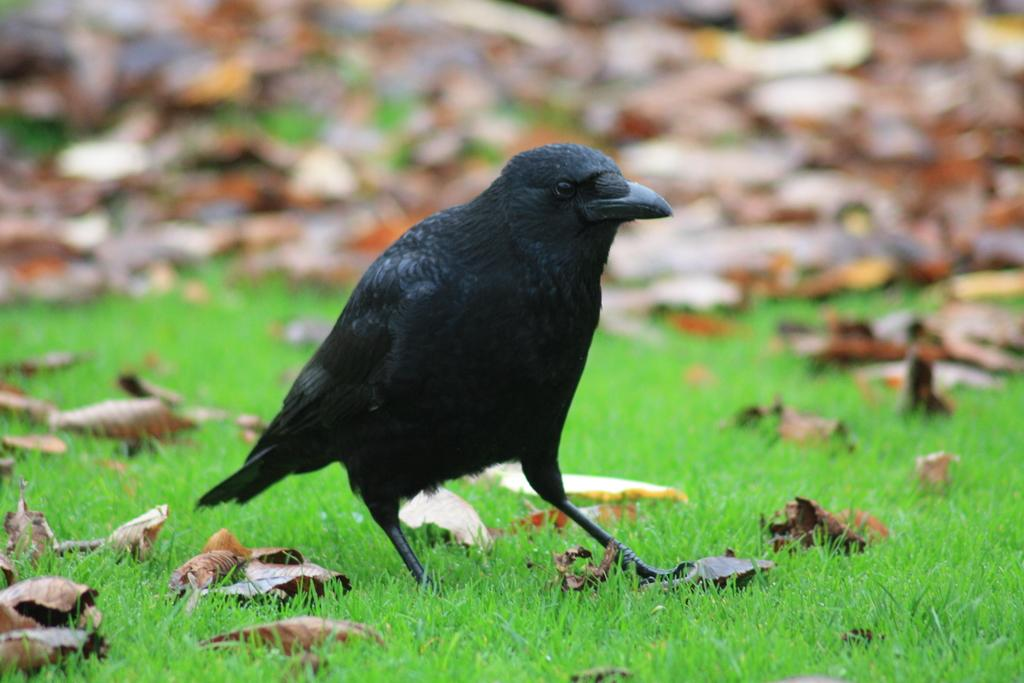What type of bird is in the image? There is a crow in the image. Where is the crow located? The crow is standing on the grass. Can you describe the background of the image? The background of the image is blurry. What is the result of the division in the image? There is no division present in the image, as it features a crow standing on the grass with a blurry background. 